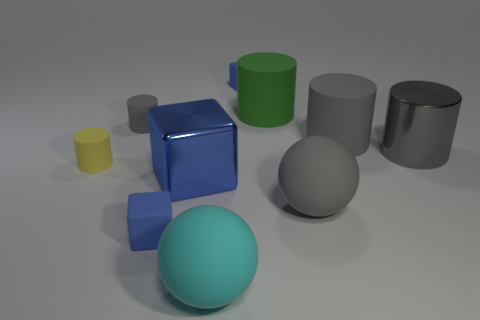What is the shape of the small yellow thing that is the same material as the tiny gray cylinder?
Make the answer very short. Cylinder. Is there anything else that is the same color as the metal cylinder?
Keep it short and to the point. Yes. What material is the big green thing that is the same shape as the tiny gray thing?
Provide a succinct answer. Rubber. How many other things are there of the same size as the green cylinder?
Ensure brevity in your answer.  5. There is a rubber ball that is the same color as the large metal cylinder; what size is it?
Make the answer very short. Large. There is a metallic object that is behind the big cube; does it have the same shape as the yellow thing?
Give a very brief answer. Yes. What number of other objects are there of the same shape as the yellow thing?
Give a very brief answer. 4. There is a yellow rubber thing in front of the shiny cylinder; what shape is it?
Make the answer very short. Cylinder. Are there any large things made of the same material as the small gray thing?
Make the answer very short. Yes. Is the color of the large sphere that is to the right of the green cylinder the same as the metallic cylinder?
Offer a terse response. Yes. 